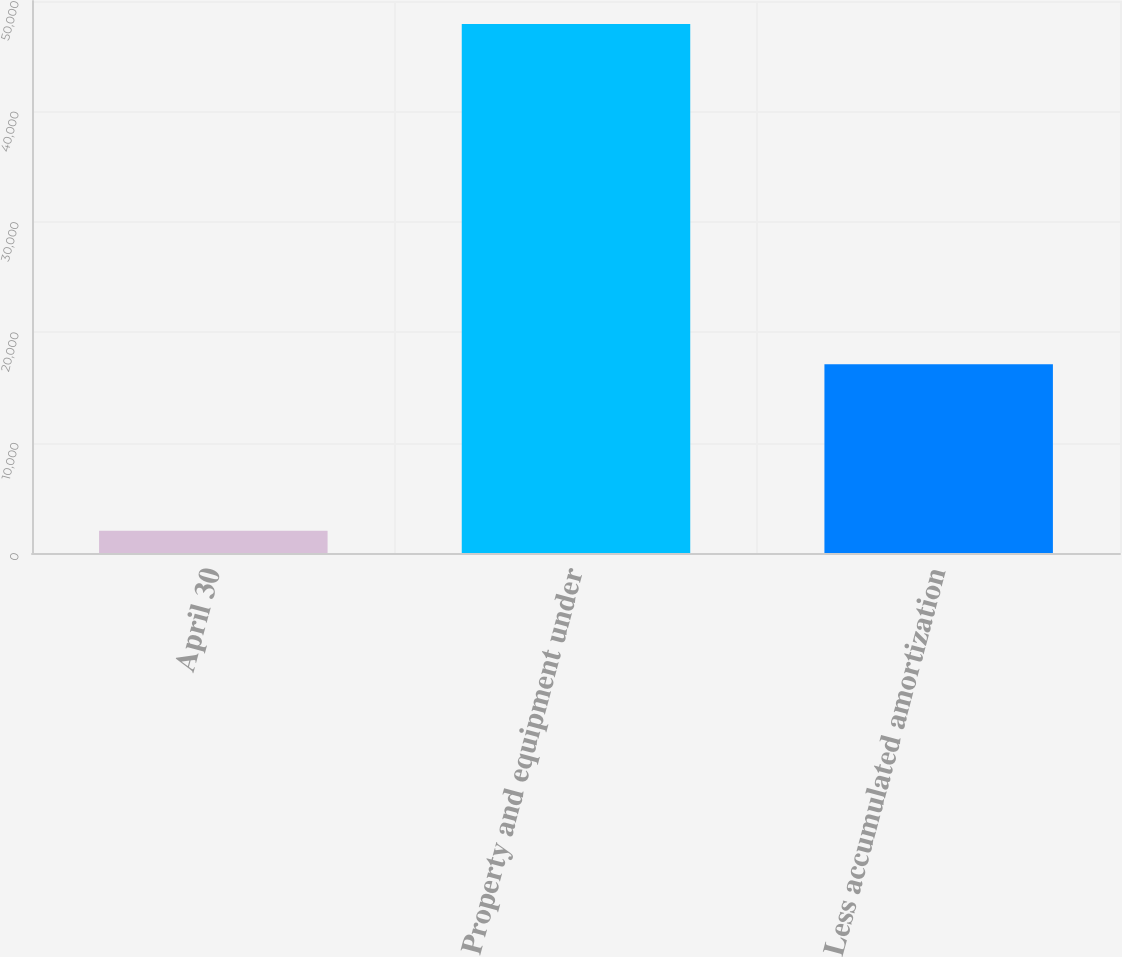Convert chart to OTSL. <chart><loc_0><loc_0><loc_500><loc_500><bar_chart><fcel>April 30<fcel>Property and equipment under<fcel>Less accumulated amortization<nl><fcel>2008<fcel>47913<fcel>17090<nl></chart> 